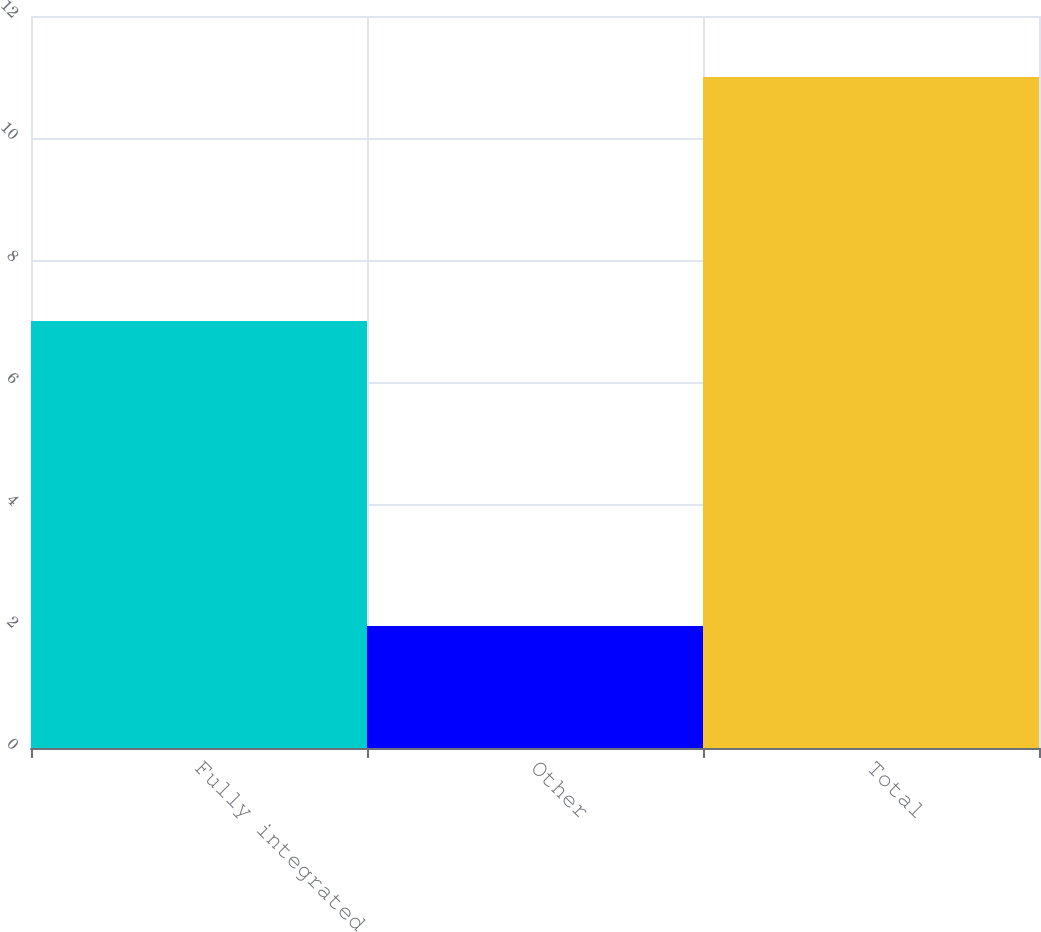<chart> <loc_0><loc_0><loc_500><loc_500><bar_chart><fcel>Fully integrated<fcel>Other<fcel>Total<nl><fcel>7<fcel>2<fcel>11<nl></chart> 